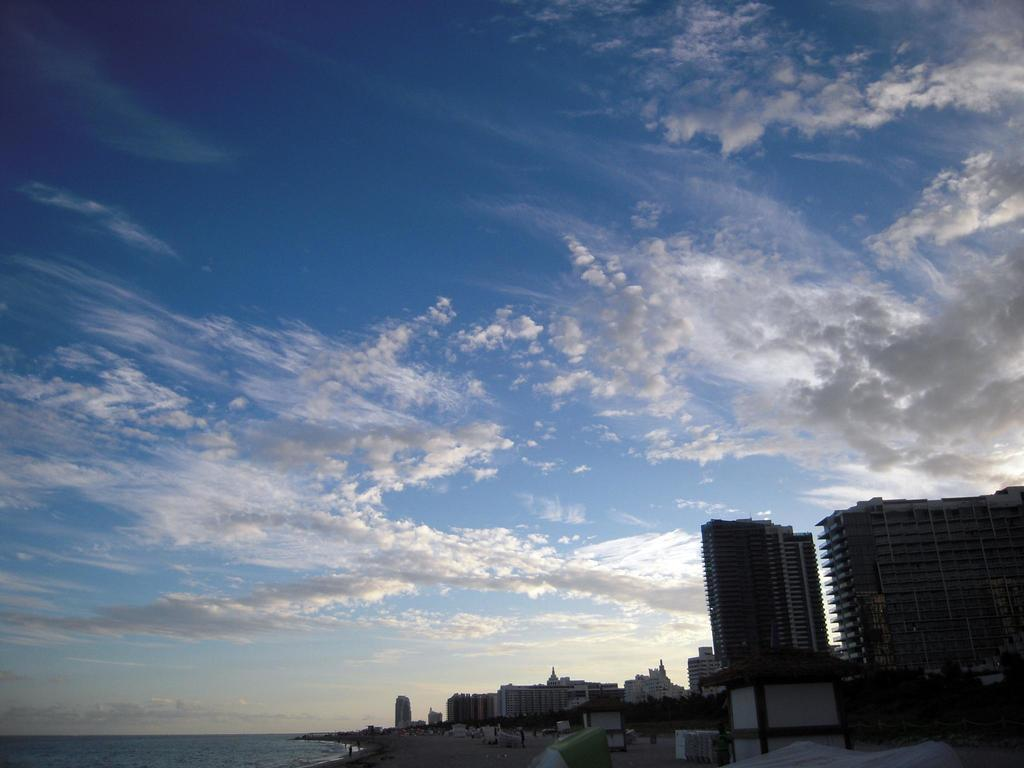What type of structures can be seen in the image? There are buildings in the image. Who or what else is present in the image? There are people and trees visible in the image. What natural element can be seen in the image? There is water visible in the image. What else is present in the image besides the people, trees, and water? There are objects in the image. What can be seen in the background of the image? The sky is visible in the background of the image, and there are clouds in the sky. What type of error can be seen in the image? There is no error present in the image. What kind of umbrella is being used by the people in the image? There are no umbrellas present in the image. 